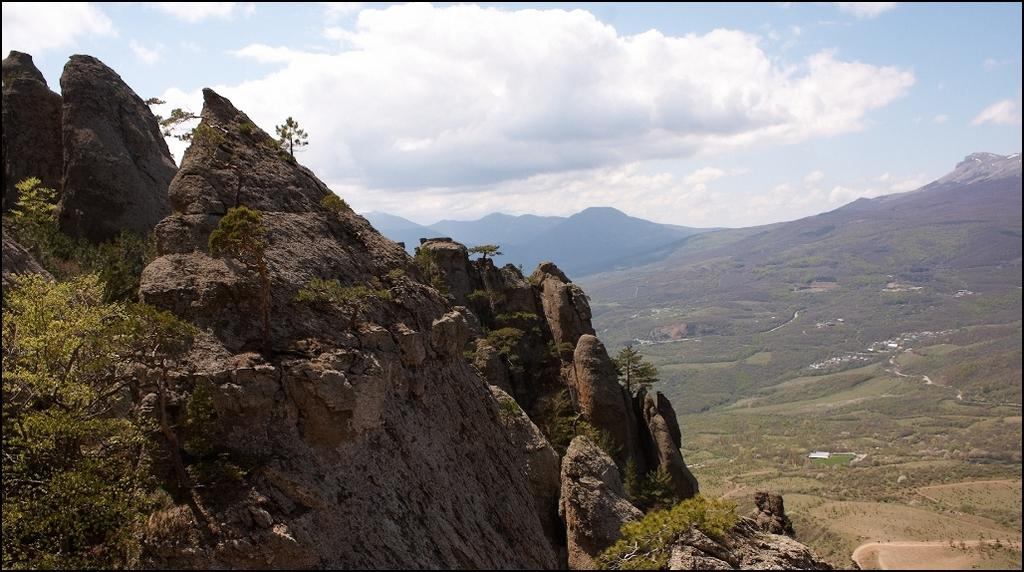What type of vegetation can be seen in the image? There is a group of trees and plants on the hills visible in the image. What natural feature can be seen in the image? There is a water body visible in the image. Are there any trees visible in the image? Yes, there is a group of trees visible in the image. What type of geographical feature is present in the image? The mountains are present in the image. What is the condition of the sky in the image? The sky is visible in the image and appears cloudy. What thoughts are going through the trees' minds in the image? Trees do not have minds or thoughts, so this question cannot be answered. What part of the brain is responsible for the trees' growth in the image? Trees do not have brains, so this question cannot be answered. 